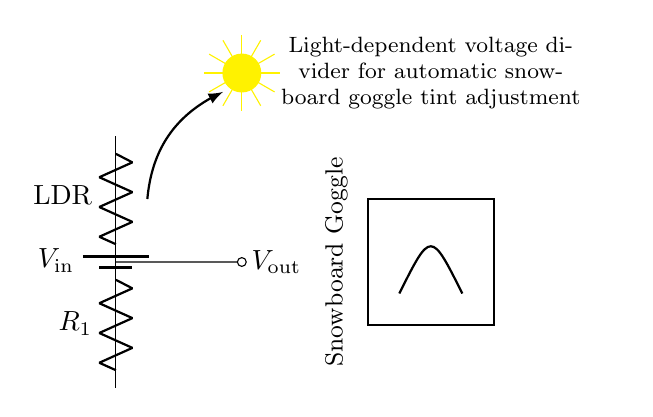what components are in this circuit? The circuit contains a light-dependent resistor (LDR), a fixed resistor (R1), and a power supply (battery).
Answer: LDR, R1, battery what is V out in this circuit dependent on? V out is dependent on the resistance of the LDR, which changes with light intensity.
Answer: Light intensity how many resistors are present in the circuit? There are two resistors in this circuit: the LDR and the fixed resistor R1.
Answer: Two what happens to V out when the light intensity increases? When light intensity increases, the resistance of the LDR decreases, leading to a higher output voltage (V out).
Answer: V out increases what type of voltage divider is shown in the circuit? This is a light-dependent voltage divider, as it uses an LDR to adjust the output voltage based on light conditions.
Answer: Light-dependent how does the output voltage change when the LDR gets less light? When the LDR gets less light, its resistance increases, causing a decrease in the output voltage (V out).
Answer: V out decreases what is the function of the snowboard goggles in the circuit? The snowboard goggles adjust their tint based on the output voltage from the voltage divider circuit, providing optimal visibility.
Answer: Tint adjustment 